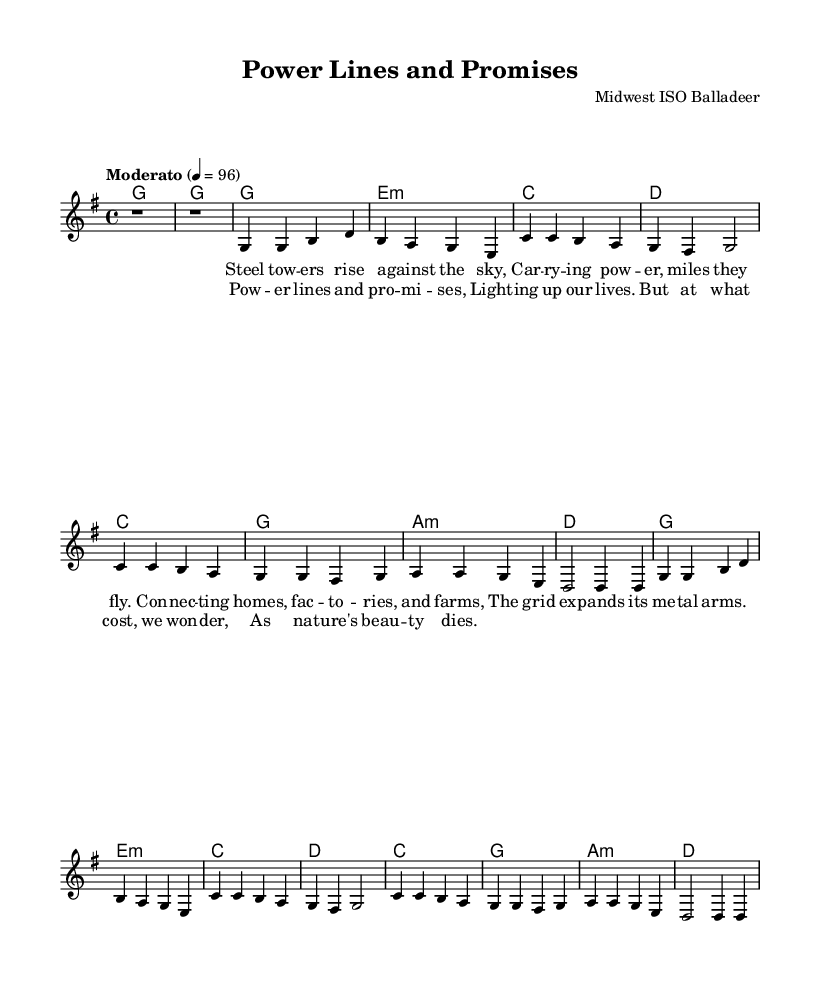What is the key signature of this music? The key signature is G major, which contains one sharp (F#). This can be identified by looking at the key signature symbol placed at the beginning of the staff.
Answer: G major What is the time signature of this music? The time signature is 4/4, which is indicated at the beginning of the music. This means there are four beats in each measure and the quarter note gets one beat.
Answer: 4/4 What is the tempo marking for this piece? The tempo marking is marked as "Moderato" with a metronome marking of 96 beats per minute, seen at the start of the score. "Moderato" indicates a moderate pace.
Answer: Moderato How many measures are in the verses? Each verse section consists of four measures, following a clear repeating structure. This is determined by counting the measures as defined in the melody lines.
Answer: Four What is the dynamic of the chorus? The chorus does not specify a dynamic marking directly in the provided music, but folk songs often imply a building volume. This requires inferring the value based on song structure rather than direct notation.
Answer: None specified What type of song structure does this piece reflect? The song reflects a Verse-Chorus format, typical of folk music. This can be inferred as the melody alternates between the verse and chorus sections, common in folk traditions.
Answer: Verse-Chorus 